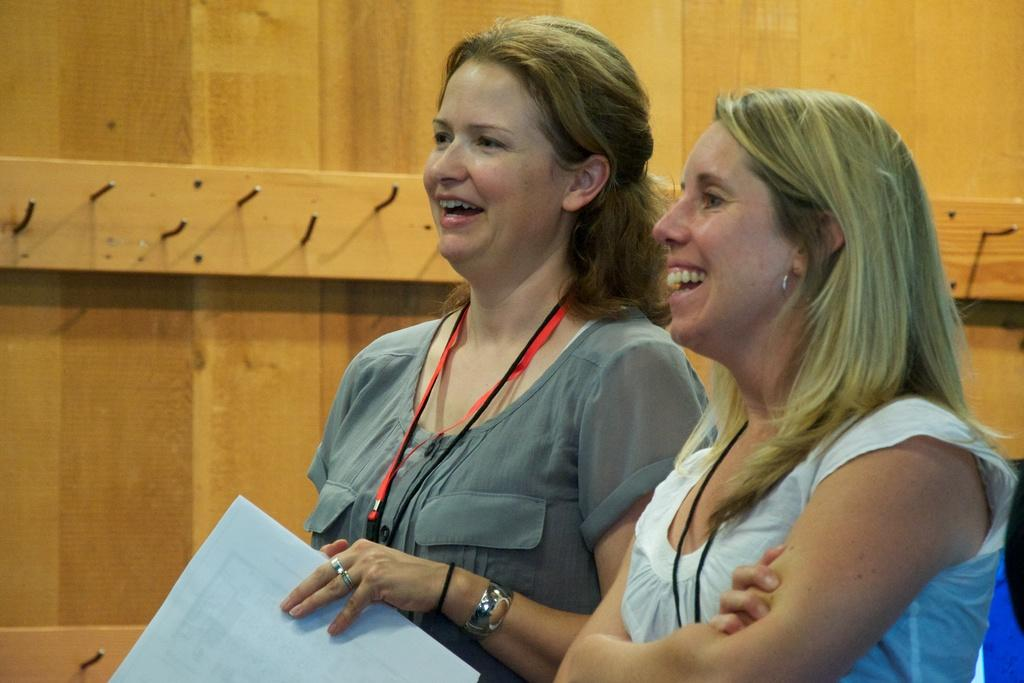How many people are in the image? There are two women in the image. What is one of the women holding? One of the women is holding a paper. What can be seen in the background of the image? There are metal rods on a wall in the background of the image. What type of ink is being used to make a statement on the exchange in the image? There is no exchange or statement being made in the image, and no ink is visible. 